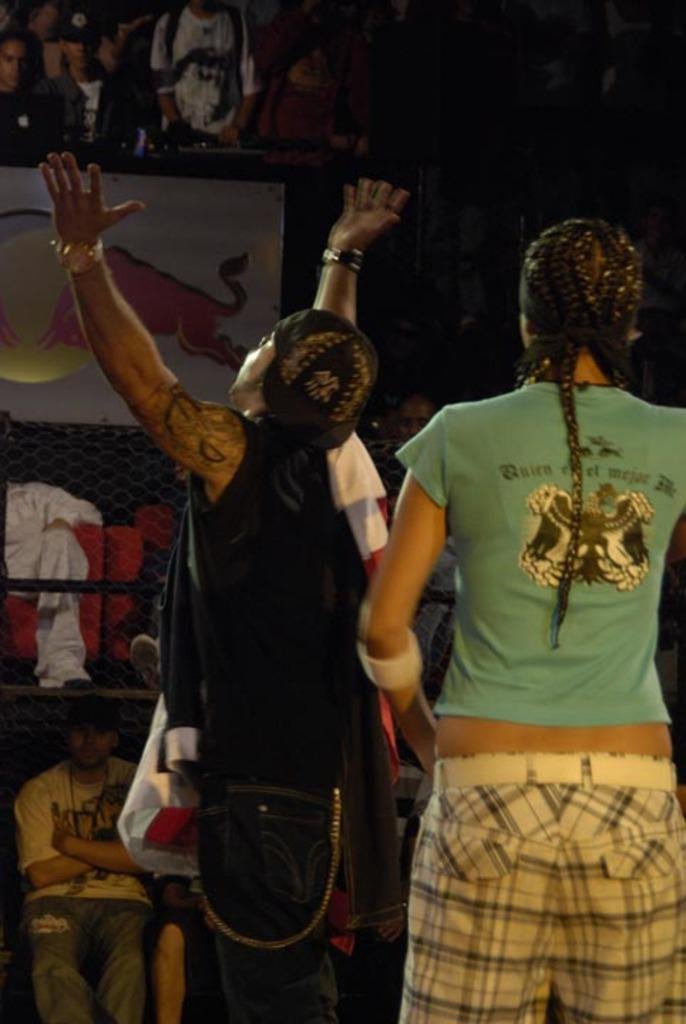Who or what can be seen in the image? There are people in the image. What type of material or structure is present in the image? There is a mesh in the image. What other object can be seen in the image? There is a board in the image. What type of teeth can be seen on the board in the image? There are no teeth present on the board in the image. 